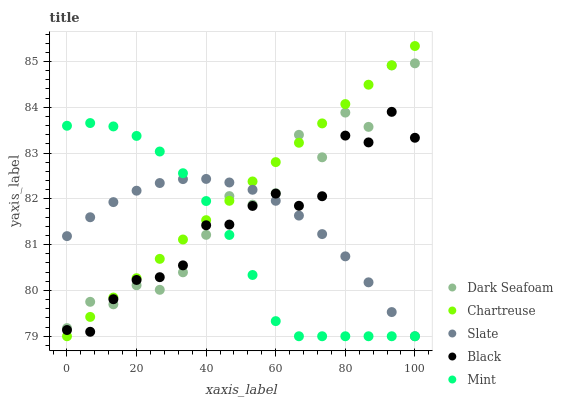Does Mint have the minimum area under the curve?
Answer yes or no. Yes. Does Chartreuse have the maximum area under the curve?
Answer yes or no. Yes. Does Dark Seafoam have the minimum area under the curve?
Answer yes or no. No. Does Dark Seafoam have the maximum area under the curve?
Answer yes or no. No. Is Chartreuse the smoothest?
Answer yes or no. Yes. Is Dark Seafoam the roughest?
Answer yes or no. Yes. Is Slate the smoothest?
Answer yes or no. No. Is Slate the roughest?
Answer yes or no. No. Does Mint have the lowest value?
Answer yes or no. Yes. Does Dark Seafoam have the lowest value?
Answer yes or no. No. Does Chartreuse have the highest value?
Answer yes or no. Yes. Does Dark Seafoam have the highest value?
Answer yes or no. No. Does Slate intersect Dark Seafoam?
Answer yes or no. Yes. Is Slate less than Dark Seafoam?
Answer yes or no. No. Is Slate greater than Dark Seafoam?
Answer yes or no. No. 